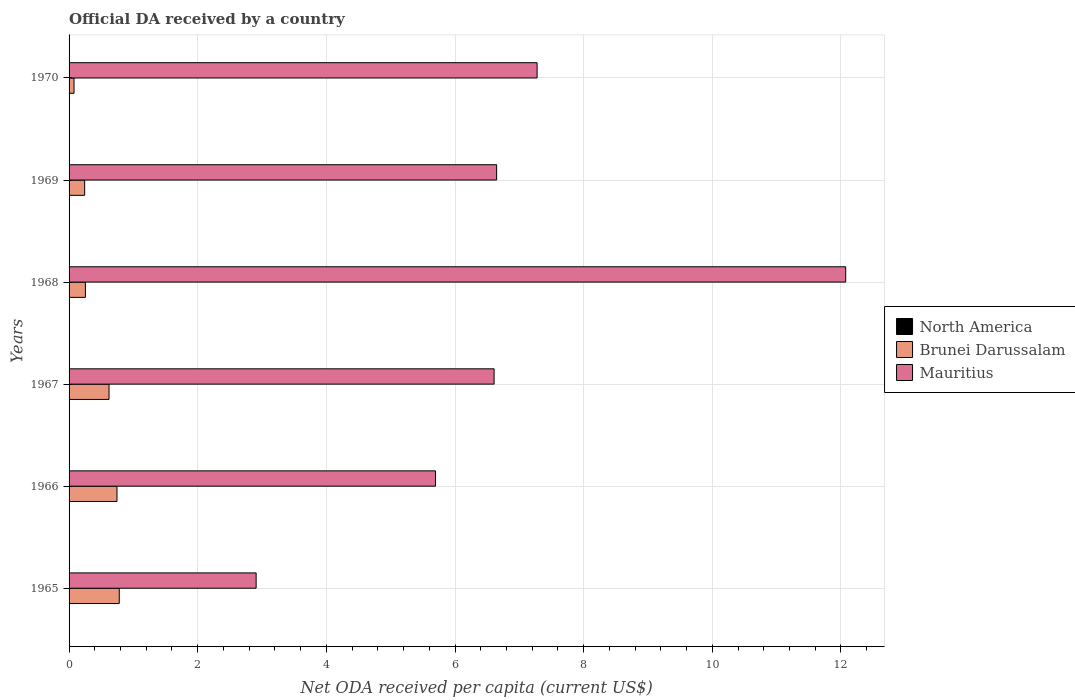How many different coloured bars are there?
Keep it short and to the point. 3. Are the number of bars on each tick of the Y-axis equal?
Give a very brief answer. Yes. How many bars are there on the 2nd tick from the bottom?
Ensure brevity in your answer.  3. What is the label of the 2nd group of bars from the top?
Give a very brief answer. 1969. What is the ODA received in in North America in 1965?
Offer a very short reply. 0. Across all years, what is the maximum ODA received in in North America?
Your answer should be very brief. 0. Across all years, what is the minimum ODA received in in North America?
Provide a succinct answer. 4.41635641762833e-5. In which year was the ODA received in in Brunei Darussalam maximum?
Provide a short and direct response. 1965. In which year was the ODA received in in Mauritius minimum?
Make the answer very short. 1965. What is the total ODA received in in Mauritius in the graph?
Offer a terse response. 41.21. What is the difference between the ODA received in in North America in 1966 and that in 1967?
Your answer should be compact. 3.1802754366789783e-6. What is the difference between the ODA received in in North America in 1965 and the ODA received in in Mauritius in 1969?
Offer a very short reply. -6.65. What is the average ODA received in in Brunei Darussalam per year?
Provide a succinct answer. 0.45. In the year 1967, what is the difference between the ODA received in in North America and ODA received in in Brunei Darussalam?
Provide a short and direct response. -0.62. In how many years, is the ODA received in in Brunei Darussalam greater than 5.2 US$?
Keep it short and to the point. 0. What is the ratio of the ODA received in in Mauritius in 1965 to that in 1966?
Offer a very short reply. 0.51. Is the ODA received in in Brunei Darussalam in 1966 less than that in 1970?
Offer a very short reply. No. Is the difference between the ODA received in in North America in 1967 and 1970 greater than the difference between the ODA received in in Brunei Darussalam in 1967 and 1970?
Offer a terse response. No. What is the difference between the highest and the second highest ODA received in in North America?
Your response must be concise. 3.1802754366789783e-6. What is the difference between the highest and the lowest ODA received in in North America?
Your answer should be compact. 0. Is the sum of the ODA received in in Mauritius in 1968 and 1970 greater than the maximum ODA received in in North America across all years?
Your response must be concise. Yes. What does the 3rd bar from the top in 1966 represents?
Your answer should be very brief. North America. Is it the case that in every year, the sum of the ODA received in in Brunei Darussalam and ODA received in in Mauritius is greater than the ODA received in in North America?
Your response must be concise. Yes. Are all the bars in the graph horizontal?
Provide a succinct answer. Yes. How many years are there in the graph?
Provide a short and direct response. 6. Does the graph contain any zero values?
Your answer should be compact. No. Does the graph contain grids?
Your answer should be very brief. Yes. Where does the legend appear in the graph?
Offer a very short reply. Center right. What is the title of the graph?
Offer a very short reply. Official DA received by a country. Does "Tajikistan" appear as one of the legend labels in the graph?
Make the answer very short. No. What is the label or title of the X-axis?
Offer a terse response. Net ODA received per capita (current US$). What is the label or title of the Y-axis?
Your response must be concise. Years. What is the Net ODA received per capita (current US$) of North America in 1965?
Your answer should be compact. 0. What is the Net ODA received per capita (current US$) of Brunei Darussalam in 1965?
Your answer should be compact. 0.78. What is the Net ODA received per capita (current US$) of Mauritius in 1965?
Your response must be concise. 2.91. What is the Net ODA received per capita (current US$) in North America in 1966?
Keep it short and to the point. 0. What is the Net ODA received per capita (current US$) of Brunei Darussalam in 1966?
Offer a terse response. 0.74. What is the Net ODA received per capita (current US$) in Mauritius in 1966?
Offer a very short reply. 5.7. What is the Net ODA received per capita (current US$) in North America in 1967?
Your answer should be compact. 0. What is the Net ODA received per capita (current US$) in Brunei Darussalam in 1967?
Make the answer very short. 0.62. What is the Net ODA received per capita (current US$) in Mauritius in 1967?
Your answer should be very brief. 6.61. What is the Net ODA received per capita (current US$) in North America in 1968?
Your answer should be compact. 0. What is the Net ODA received per capita (current US$) in Brunei Darussalam in 1968?
Provide a succinct answer. 0.25. What is the Net ODA received per capita (current US$) of Mauritius in 1968?
Your answer should be very brief. 12.07. What is the Net ODA received per capita (current US$) in North America in 1969?
Ensure brevity in your answer.  4.46909398057732e-5. What is the Net ODA received per capita (current US$) in Brunei Darussalam in 1969?
Your response must be concise. 0.24. What is the Net ODA received per capita (current US$) of Mauritius in 1969?
Provide a succinct answer. 6.65. What is the Net ODA received per capita (current US$) in North America in 1970?
Offer a terse response. 4.41635641762833e-5. What is the Net ODA received per capita (current US$) in Brunei Darussalam in 1970?
Your answer should be very brief. 0.08. What is the Net ODA received per capita (current US$) of Mauritius in 1970?
Keep it short and to the point. 7.28. Across all years, what is the maximum Net ODA received per capita (current US$) in North America?
Give a very brief answer. 0. Across all years, what is the maximum Net ODA received per capita (current US$) in Brunei Darussalam?
Keep it short and to the point. 0.78. Across all years, what is the maximum Net ODA received per capita (current US$) in Mauritius?
Make the answer very short. 12.07. Across all years, what is the minimum Net ODA received per capita (current US$) in North America?
Your answer should be compact. 4.41635641762833e-5. Across all years, what is the minimum Net ODA received per capita (current US$) in Brunei Darussalam?
Give a very brief answer. 0.08. Across all years, what is the minimum Net ODA received per capita (current US$) in Mauritius?
Offer a very short reply. 2.91. What is the total Net ODA received per capita (current US$) of North America in the graph?
Keep it short and to the point. 0. What is the total Net ODA received per capita (current US$) of Brunei Darussalam in the graph?
Give a very brief answer. 2.72. What is the total Net ODA received per capita (current US$) in Mauritius in the graph?
Keep it short and to the point. 41.21. What is the difference between the Net ODA received per capita (current US$) of North America in 1965 and that in 1966?
Your answer should be very brief. -0. What is the difference between the Net ODA received per capita (current US$) in Brunei Darussalam in 1965 and that in 1966?
Offer a very short reply. 0.04. What is the difference between the Net ODA received per capita (current US$) of Mauritius in 1965 and that in 1966?
Provide a succinct answer. -2.79. What is the difference between the Net ODA received per capita (current US$) of North America in 1965 and that in 1967?
Provide a succinct answer. -0. What is the difference between the Net ODA received per capita (current US$) of Brunei Darussalam in 1965 and that in 1967?
Ensure brevity in your answer.  0.16. What is the difference between the Net ODA received per capita (current US$) of Mauritius in 1965 and that in 1967?
Your answer should be very brief. -3.7. What is the difference between the Net ODA received per capita (current US$) in North America in 1965 and that in 1968?
Your answer should be very brief. 0. What is the difference between the Net ODA received per capita (current US$) of Brunei Darussalam in 1965 and that in 1968?
Provide a succinct answer. 0.53. What is the difference between the Net ODA received per capita (current US$) in Mauritius in 1965 and that in 1968?
Provide a succinct answer. -9.17. What is the difference between the Net ODA received per capita (current US$) in North America in 1965 and that in 1969?
Offer a very short reply. 0. What is the difference between the Net ODA received per capita (current US$) of Brunei Darussalam in 1965 and that in 1969?
Keep it short and to the point. 0.54. What is the difference between the Net ODA received per capita (current US$) in Mauritius in 1965 and that in 1969?
Your answer should be very brief. -3.74. What is the difference between the Net ODA received per capita (current US$) in Brunei Darussalam in 1965 and that in 1970?
Provide a short and direct response. 0.7. What is the difference between the Net ODA received per capita (current US$) in Mauritius in 1965 and that in 1970?
Give a very brief answer. -4.37. What is the difference between the Net ODA received per capita (current US$) of Brunei Darussalam in 1966 and that in 1967?
Your answer should be compact. 0.12. What is the difference between the Net ODA received per capita (current US$) of Mauritius in 1966 and that in 1967?
Ensure brevity in your answer.  -0.91. What is the difference between the Net ODA received per capita (current US$) in North America in 1966 and that in 1968?
Offer a very short reply. 0. What is the difference between the Net ODA received per capita (current US$) of Brunei Darussalam in 1966 and that in 1968?
Your answer should be compact. 0.49. What is the difference between the Net ODA received per capita (current US$) in Mauritius in 1966 and that in 1968?
Give a very brief answer. -6.38. What is the difference between the Net ODA received per capita (current US$) of Brunei Darussalam in 1966 and that in 1969?
Your answer should be compact. 0.5. What is the difference between the Net ODA received per capita (current US$) of Mauritius in 1966 and that in 1969?
Provide a short and direct response. -0.95. What is the difference between the Net ODA received per capita (current US$) in Brunei Darussalam in 1966 and that in 1970?
Make the answer very short. 0.67. What is the difference between the Net ODA received per capita (current US$) in Mauritius in 1966 and that in 1970?
Provide a short and direct response. -1.58. What is the difference between the Net ODA received per capita (current US$) of North America in 1967 and that in 1968?
Ensure brevity in your answer.  0. What is the difference between the Net ODA received per capita (current US$) of Brunei Darussalam in 1967 and that in 1968?
Give a very brief answer. 0.37. What is the difference between the Net ODA received per capita (current US$) of Mauritius in 1967 and that in 1968?
Offer a very short reply. -5.47. What is the difference between the Net ODA received per capita (current US$) in Brunei Darussalam in 1967 and that in 1969?
Offer a very short reply. 0.38. What is the difference between the Net ODA received per capita (current US$) in Mauritius in 1967 and that in 1969?
Provide a succinct answer. -0.04. What is the difference between the Net ODA received per capita (current US$) of North America in 1967 and that in 1970?
Ensure brevity in your answer.  0. What is the difference between the Net ODA received per capita (current US$) of Brunei Darussalam in 1967 and that in 1970?
Make the answer very short. 0.54. What is the difference between the Net ODA received per capita (current US$) in Mauritius in 1967 and that in 1970?
Your answer should be very brief. -0.67. What is the difference between the Net ODA received per capita (current US$) of Brunei Darussalam in 1968 and that in 1969?
Provide a succinct answer. 0.01. What is the difference between the Net ODA received per capita (current US$) of Mauritius in 1968 and that in 1969?
Offer a terse response. 5.43. What is the difference between the Net ODA received per capita (current US$) of Brunei Darussalam in 1968 and that in 1970?
Keep it short and to the point. 0.18. What is the difference between the Net ODA received per capita (current US$) in Mauritius in 1968 and that in 1970?
Offer a very short reply. 4.8. What is the difference between the Net ODA received per capita (current US$) of North America in 1969 and that in 1970?
Offer a very short reply. 0. What is the difference between the Net ODA received per capita (current US$) in Brunei Darussalam in 1969 and that in 1970?
Keep it short and to the point. 0.17. What is the difference between the Net ODA received per capita (current US$) in Mauritius in 1969 and that in 1970?
Give a very brief answer. -0.63. What is the difference between the Net ODA received per capita (current US$) in North America in 1965 and the Net ODA received per capita (current US$) in Brunei Darussalam in 1966?
Your answer should be very brief. -0.74. What is the difference between the Net ODA received per capita (current US$) of North America in 1965 and the Net ODA received per capita (current US$) of Mauritius in 1966?
Give a very brief answer. -5.7. What is the difference between the Net ODA received per capita (current US$) of Brunei Darussalam in 1965 and the Net ODA received per capita (current US$) of Mauritius in 1966?
Provide a short and direct response. -4.92. What is the difference between the Net ODA received per capita (current US$) in North America in 1965 and the Net ODA received per capita (current US$) in Brunei Darussalam in 1967?
Offer a terse response. -0.62. What is the difference between the Net ODA received per capita (current US$) in North America in 1965 and the Net ODA received per capita (current US$) in Mauritius in 1967?
Provide a succinct answer. -6.61. What is the difference between the Net ODA received per capita (current US$) of Brunei Darussalam in 1965 and the Net ODA received per capita (current US$) of Mauritius in 1967?
Your answer should be compact. -5.83. What is the difference between the Net ODA received per capita (current US$) of North America in 1965 and the Net ODA received per capita (current US$) of Brunei Darussalam in 1968?
Give a very brief answer. -0.25. What is the difference between the Net ODA received per capita (current US$) of North America in 1965 and the Net ODA received per capita (current US$) of Mauritius in 1968?
Offer a very short reply. -12.07. What is the difference between the Net ODA received per capita (current US$) in Brunei Darussalam in 1965 and the Net ODA received per capita (current US$) in Mauritius in 1968?
Give a very brief answer. -11.29. What is the difference between the Net ODA received per capita (current US$) in North America in 1965 and the Net ODA received per capita (current US$) in Brunei Darussalam in 1969?
Your answer should be compact. -0.24. What is the difference between the Net ODA received per capita (current US$) of North America in 1965 and the Net ODA received per capita (current US$) of Mauritius in 1969?
Provide a succinct answer. -6.65. What is the difference between the Net ODA received per capita (current US$) in Brunei Darussalam in 1965 and the Net ODA received per capita (current US$) in Mauritius in 1969?
Offer a very short reply. -5.87. What is the difference between the Net ODA received per capita (current US$) in North America in 1965 and the Net ODA received per capita (current US$) in Brunei Darussalam in 1970?
Give a very brief answer. -0.08. What is the difference between the Net ODA received per capita (current US$) of North America in 1965 and the Net ODA received per capita (current US$) of Mauritius in 1970?
Provide a short and direct response. -7.28. What is the difference between the Net ODA received per capita (current US$) in Brunei Darussalam in 1965 and the Net ODA received per capita (current US$) in Mauritius in 1970?
Ensure brevity in your answer.  -6.5. What is the difference between the Net ODA received per capita (current US$) in North America in 1966 and the Net ODA received per capita (current US$) in Brunei Darussalam in 1967?
Offer a terse response. -0.62. What is the difference between the Net ODA received per capita (current US$) of North America in 1966 and the Net ODA received per capita (current US$) of Mauritius in 1967?
Provide a short and direct response. -6.61. What is the difference between the Net ODA received per capita (current US$) in Brunei Darussalam in 1966 and the Net ODA received per capita (current US$) in Mauritius in 1967?
Your answer should be compact. -5.86. What is the difference between the Net ODA received per capita (current US$) in North America in 1966 and the Net ODA received per capita (current US$) in Brunei Darussalam in 1968?
Offer a very short reply. -0.25. What is the difference between the Net ODA received per capita (current US$) in North America in 1966 and the Net ODA received per capita (current US$) in Mauritius in 1968?
Ensure brevity in your answer.  -12.07. What is the difference between the Net ODA received per capita (current US$) in Brunei Darussalam in 1966 and the Net ODA received per capita (current US$) in Mauritius in 1968?
Your answer should be compact. -11.33. What is the difference between the Net ODA received per capita (current US$) of North America in 1966 and the Net ODA received per capita (current US$) of Brunei Darussalam in 1969?
Your answer should be compact. -0.24. What is the difference between the Net ODA received per capita (current US$) in North America in 1966 and the Net ODA received per capita (current US$) in Mauritius in 1969?
Provide a succinct answer. -6.65. What is the difference between the Net ODA received per capita (current US$) of Brunei Darussalam in 1966 and the Net ODA received per capita (current US$) of Mauritius in 1969?
Provide a short and direct response. -5.9. What is the difference between the Net ODA received per capita (current US$) of North America in 1966 and the Net ODA received per capita (current US$) of Brunei Darussalam in 1970?
Offer a terse response. -0.08. What is the difference between the Net ODA received per capita (current US$) in North America in 1966 and the Net ODA received per capita (current US$) in Mauritius in 1970?
Make the answer very short. -7.28. What is the difference between the Net ODA received per capita (current US$) of Brunei Darussalam in 1966 and the Net ODA received per capita (current US$) of Mauritius in 1970?
Offer a terse response. -6.53. What is the difference between the Net ODA received per capita (current US$) in North America in 1967 and the Net ODA received per capita (current US$) in Brunei Darussalam in 1968?
Your response must be concise. -0.25. What is the difference between the Net ODA received per capita (current US$) in North America in 1967 and the Net ODA received per capita (current US$) in Mauritius in 1968?
Your answer should be very brief. -12.07. What is the difference between the Net ODA received per capita (current US$) in Brunei Darussalam in 1967 and the Net ODA received per capita (current US$) in Mauritius in 1968?
Offer a terse response. -11.45. What is the difference between the Net ODA received per capita (current US$) of North America in 1967 and the Net ODA received per capita (current US$) of Brunei Darussalam in 1969?
Your answer should be compact. -0.24. What is the difference between the Net ODA received per capita (current US$) in North America in 1967 and the Net ODA received per capita (current US$) in Mauritius in 1969?
Your answer should be compact. -6.65. What is the difference between the Net ODA received per capita (current US$) in Brunei Darussalam in 1967 and the Net ODA received per capita (current US$) in Mauritius in 1969?
Your answer should be compact. -6.03. What is the difference between the Net ODA received per capita (current US$) in North America in 1967 and the Net ODA received per capita (current US$) in Brunei Darussalam in 1970?
Keep it short and to the point. -0.08. What is the difference between the Net ODA received per capita (current US$) in North America in 1967 and the Net ODA received per capita (current US$) in Mauritius in 1970?
Make the answer very short. -7.28. What is the difference between the Net ODA received per capita (current US$) in Brunei Darussalam in 1967 and the Net ODA received per capita (current US$) in Mauritius in 1970?
Offer a very short reply. -6.65. What is the difference between the Net ODA received per capita (current US$) of North America in 1968 and the Net ODA received per capita (current US$) of Brunei Darussalam in 1969?
Ensure brevity in your answer.  -0.24. What is the difference between the Net ODA received per capita (current US$) in North America in 1968 and the Net ODA received per capita (current US$) in Mauritius in 1969?
Offer a very short reply. -6.65. What is the difference between the Net ODA received per capita (current US$) of Brunei Darussalam in 1968 and the Net ODA received per capita (current US$) of Mauritius in 1969?
Make the answer very short. -6.39. What is the difference between the Net ODA received per capita (current US$) in North America in 1968 and the Net ODA received per capita (current US$) in Brunei Darussalam in 1970?
Your answer should be very brief. -0.08. What is the difference between the Net ODA received per capita (current US$) of North America in 1968 and the Net ODA received per capita (current US$) of Mauritius in 1970?
Provide a succinct answer. -7.28. What is the difference between the Net ODA received per capita (current US$) in Brunei Darussalam in 1968 and the Net ODA received per capita (current US$) in Mauritius in 1970?
Ensure brevity in your answer.  -7.02. What is the difference between the Net ODA received per capita (current US$) of North America in 1969 and the Net ODA received per capita (current US$) of Brunei Darussalam in 1970?
Ensure brevity in your answer.  -0.08. What is the difference between the Net ODA received per capita (current US$) in North America in 1969 and the Net ODA received per capita (current US$) in Mauritius in 1970?
Provide a succinct answer. -7.28. What is the difference between the Net ODA received per capita (current US$) in Brunei Darussalam in 1969 and the Net ODA received per capita (current US$) in Mauritius in 1970?
Ensure brevity in your answer.  -7.03. What is the average Net ODA received per capita (current US$) of Brunei Darussalam per year?
Your answer should be compact. 0.45. What is the average Net ODA received per capita (current US$) of Mauritius per year?
Your answer should be very brief. 6.87. In the year 1965, what is the difference between the Net ODA received per capita (current US$) in North America and Net ODA received per capita (current US$) in Brunei Darussalam?
Offer a terse response. -0.78. In the year 1965, what is the difference between the Net ODA received per capita (current US$) in North America and Net ODA received per capita (current US$) in Mauritius?
Provide a short and direct response. -2.91. In the year 1965, what is the difference between the Net ODA received per capita (current US$) in Brunei Darussalam and Net ODA received per capita (current US$) in Mauritius?
Offer a very short reply. -2.13. In the year 1966, what is the difference between the Net ODA received per capita (current US$) in North America and Net ODA received per capita (current US$) in Brunei Darussalam?
Provide a succinct answer. -0.74. In the year 1966, what is the difference between the Net ODA received per capita (current US$) in North America and Net ODA received per capita (current US$) in Mauritius?
Offer a terse response. -5.7. In the year 1966, what is the difference between the Net ODA received per capita (current US$) of Brunei Darussalam and Net ODA received per capita (current US$) of Mauritius?
Ensure brevity in your answer.  -4.95. In the year 1967, what is the difference between the Net ODA received per capita (current US$) of North America and Net ODA received per capita (current US$) of Brunei Darussalam?
Your answer should be compact. -0.62. In the year 1967, what is the difference between the Net ODA received per capita (current US$) in North America and Net ODA received per capita (current US$) in Mauritius?
Keep it short and to the point. -6.61. In the year 1967, what is the difference between the Net ODA received per capita (current US$) in Brunei Darussalam and Net ODA received per capita (current US$) in Mauritius?
Your answer should be compact. -5.99. In the year 1968, what is the difference between the Net ODA received per capita (current US$) of North America and Net ODA received per capita (current US$) of Brunei Darussalam?
Your answer should be very brief. -0.25. In the year 1968, what is the difference between the Net ODA received per capita (current US$) of North America and Net ODA received per capita (current US$) of Mauritius?
Your answer should be compact. -12.07. In the year 1968, what is the difference between the Net ODA received per capita (current US$) in Brunei Darussalam and Net ODA received per capita (current US$) in Mauritius?
Ensure brevity in your answer.  -11.82. In the year 1969, what is the difference between the Net ODA received per capita (current US$) of North America and Net ODA received per capita (current US$) of Brunei Darussalam?
Keep it short and to the point. -0.24. In the year 1969, what is the difference between the Net ODA received per capita (current US$) of North America and Net ODA received per capita (current US$) of Mauritius?
Give a very brief answer. -6.65. In the year 1969, what is the difference between the Net ODA received per capita (current US$) in Brunei Darussalam and Net ODA received per capita (current US$) in Mauritius?
Your answer should be very brief. -6.4. In the year 1970, what is the difference between the Net ODA received per capita (current US$) of North America and Net ODA received per capita (current US$) of Brunei Darussalam?
Your answer should be very brief. -0.08. In the year 1970, what is the difference between the Net ODA received per capita (current US$) in North America and Net ODA received per capita (current US$) in Mauritius?
Offer a terse response. -7.28. In the year 1970, what is the difference between the Net ODA received per capita (current US$) of Brunei Darussalam and Net ODA received per capita (current US$) of Mauritius?
Your response must be concise. -7.2. What is the ratio of the Net ODA received per capita (current US$) in North America in 1965 to that in 1966?
Provide a succinct answer. 0.84. What is the ratio of the Net ODA received per capita (current US$) in Brunei Darussalam in 1965 to that in 1966?
Offer a terse response. 1.05. What is the ratio of the Net ODA received per capita (current US$) in Mauritius in 1965 to that in 1966?
Keep it short and to the point. 0.51. What is the ratio of the Net ODA received per capita (current US$) in North America in 1965 to that in 1967?
Give a very brief answer. 0.85. What is the ratio of the Net ODA received per capita (current US$) of Brunei Darussalam in 1965 to that in 1967?
Your response must be concise. 1.26. What is the ratio of the Net ODA received per capita (current US$) of Mauritius in 1965 to that in 1967?
Offer a very short reply. 0.44. What is the ratio of the Net ODA received per capita (current US$) in North America in 1965 to that in 1968?
Make the answer very short. 1.29. What is the ratio of the Net ODA received per capita (current US$) in Brunei Darussalam in 1965 to that in 1968?
Provide a short and direct response. 3.07. What is the ratio of the Net ODA received per capita (current US$) in Mauritius in 1965 to that in 1968?
Offer a terse response. 0.24. What is the ratio of the Net ODA received per capita (current US$) of North America in 1965 to that in 1969?
Your answer should be compact. 5.23. What is the ratio of the Net ODA received per capita (current US$) of Brunei Darussalam in 1965 to that in 1969?
Your answer should be compact. 3.22. What is the ratio of the Net ODA received per capita (current US$) of Mauritius in 1965 to that in 1969?
Make the answer very short. 0.44. What is the ratio of the Net ODA received per capita (current US$) in North America in 1965 to that in 1970?
Offer a terse response. 5.29. What is the ratio of the Net ODA received per capita (current US$) of Brunei Darussalam in 1965 to that in 1970?
Keep it short and to the point. 10.12. What is the ratio of the Net ODA received per capita (current US$) of Mauritius in 1965 to that in 1970?
Ensure brevity in your answer.  0.4. What is the ratio of the Net ODA received per capita (current US$) of North America in 1966 to that in 1967?
Provide a short and direct response. 1.01. What is the ratio of the Net ODA received per capita (current US$) in Brunei Darussalam in 1966 to that in 1967?
Offer a terse response. 1.2. What is the ratio of the Net ODA received per capita (current US$) in Mauritius in 1966 to that in 1967?
Provide a short and direct response. 0.86. What is the ratio of the Net ODA received per capita (current US$) in North America in 1966 to that in 1968?
Your answer should be compact. 1.53. What is the ratio of the Net ODA received per capita (current US$) of Brunei Darussalam in 1966 to that in 1968?
Provide a short and direct response. 2.93. What is the ratio of the Net ODA received per capita (current US$) of Mauritius in 1966 to that in 1968?
Make the answer very short. 0.47. What is the ratio of the Net ODA received per capita (current US$) of North America in 1966 to that in 1969?
Offer a very short reply. 6.2. What is the ratio of the Net ODA received per capita (current US$) in Brunei Darussalam in 1966 to that in 1969?
Ensure brevity in your answer.  3.07. What is the ratio of the Net ODA received per capita (current US$) of Mauritius in 1966 to that in 1969?
Provide a short and direct response. 0.86. What is the ratio of the Net ODA received per capita (current US$) of North America in 1966 to that in 1970?
Your response must be concise. 6.27. What is the ratio of the Net ODA received per capita (current US$) in Brunei Darussalam in 1966 to that in 1970?
Your answer should be compact. 9.66. What is the ratio of the Net ODA received per capita (current US$) of Mauritius in 1966 to that in 1970?
Provide a succinct answer. 0.78. What is the ratio of the Net ODA received per capita (current US$) in North America in 1967 to that in 1968?
Make the answer very short. 1.52. What is the ratio of the Net ODA received per capita (current US$) of Brunei Darussalam in 1967 to that in 1968?
Ensure brevity in your answer.  2.45. What is the ratio of the Net ODA received per capita (current US$) in Mauritius in 1967 to that in 1968?
Keep it short and to the point. 0.55. What is the ratio of the Net ODA received per capita (current US$) of North America in 1967 to that in 1969?
Provide a succinct answer. 6.13. What is the ratio of the Net ODA received per capita (current US$) in Brunei Darussalam in 1967 to that in 1969?
Ensure brevity in your answer.  2.57. What is the ratio of the Net ODA received per capita (current US$) in North America in 1967 to that in 1970?
Provide a succinct answer. 6.2. What is the ratio of the Net ODA received per capita (current US$) in Brunei Darussalam in 1967 to that in 1970?
Keep it short and to the point. 8.06. What is the ratio of the Net ODA received per capita (current US$) of Mauritius in 1967 to that in 1970?
Give a very brief answer. 0.91. What is the ratio of the Net ODA received per capita (current US$) of North America in 1968 to that in 1969?
Provide a short and direct response. 4.04. What is the ratio of the Net ODA received per capita (current US$) of Brunei Darussalam in 1968 to that in 1969?
Make the answer very short. 1.05. What is the ratio of the Net ODA received per capita (current US$) of Mauritius in 1968 to that in 1969?
Your response must be concise. 1.82. What is the ratio of the Net ODA received per capita (current US$) of North America in 1968 to that in 1970?
Provide a succinct answer. 4.09. What is the ratio of the Net ODA received per capita (current US$) in Brunei Darussalam in 1968 to that in 1970?
Your answer should be compact. 3.29. What is the ratio of the Net ODA received per capita (current US$) in Mauritius in 1968 to that in 1970?
Keep it short and to the point. 1.66. What is the ratio of the Net ODA received per capita (current US$) of North America in 1969 to that in 1970?
Your response must be concise. 1.01. What is the ratio of the Net ODA received per capita (current US$) in Brunei Darussalam in 1969 to that in 1970?
Keep it short and to the point. 3.14. What is the ratio of the Net ODA received per capita (current US$) of Mauritius in 1969 to that in 1970?
Keep it short and to the point. 0.91. What is the difference between the highest and the second highest Net ODA received per capita (current US$) of North America?
Give a very brief answer. 0. What is the difference between the highest and the second highest Net ODA received per capita (current US$) of Brunei Darussalam?
Give a very brief answer. 0.04. What is the difference between the highest and the second highest Net ODA received per capita (current US$) of Mauritius?
Provide a short and direct response. 4.8. What is the difference between the highest and the lowest Net ODA received per capita (current US$) in Brunei Darussalam?
Keep it short and to the point. 0.7. What is the difference between the highest and the lowest Net ODA received per capita (current US$) in Mauritius?
Offer a very short reply. 9.17. 